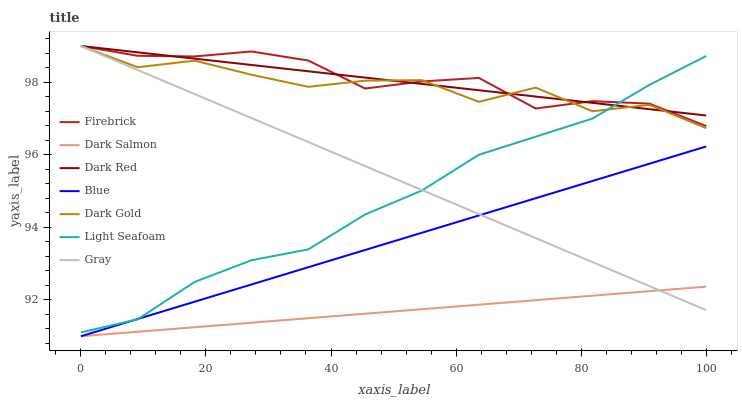Does Dark Salmon have the minimum area under the curve?
Answer yes or no. Yes. Does Firebrick have the maximum area under the curve?
Answer yes or no. Yes. Does Gray have the minimum area under the curve?
Answer yes or no. No. Does Gray have the maximum area under the curve?
Answer yes or no. No. Is Dark Red the smoothest?
Answer yes or no. Yes. Is Dark Gold the roughest?
Answer yes or no. Yes. Is Gray the smoothest?
Answer yes or no. No. Is Gray the roughest?
Answer yes or no. No. Does Blue have the lowest value?
Answer yes or no. Yes. Does Gray have the lowest value?
Answer yes or no. No. Does Firebrick have the highest value?
Answer yes or no. Yes. Does Dark Salmon have the highest value?
Answer yes or no. No. Is Dark Salmon less than Dark Red?
Answer yes or no. Yes. Is Firebrick greater than Blue?
Answer yes or no. Yes. Does Firebrick intersect Dark Red?
Answer yes or no. Yes. Is Firebrick less than Dark Red?
Answer yes or no. No. Is Firebrick greater than Dark Red?
Answer yes or no. No. Does Dark Salmon intersect Dark Red?
Answer yes or no. No. 